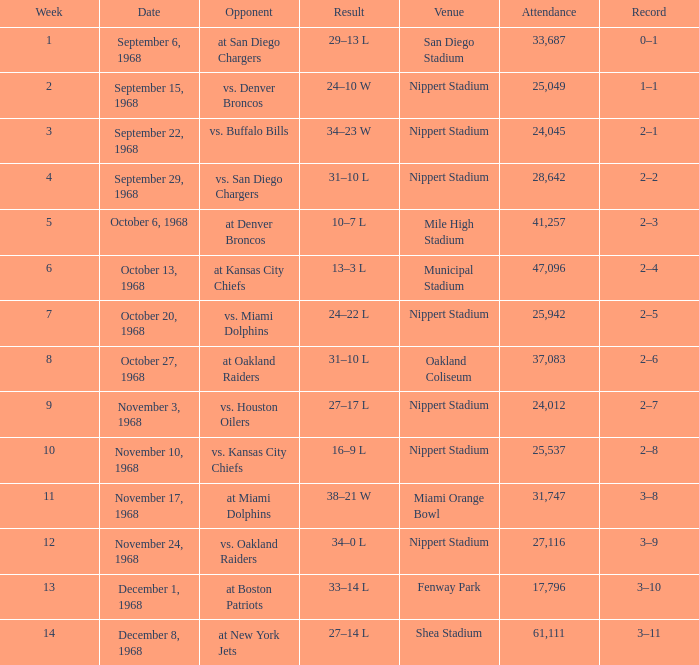In which week was the contest conducted at mile high stadium? 5.0. 